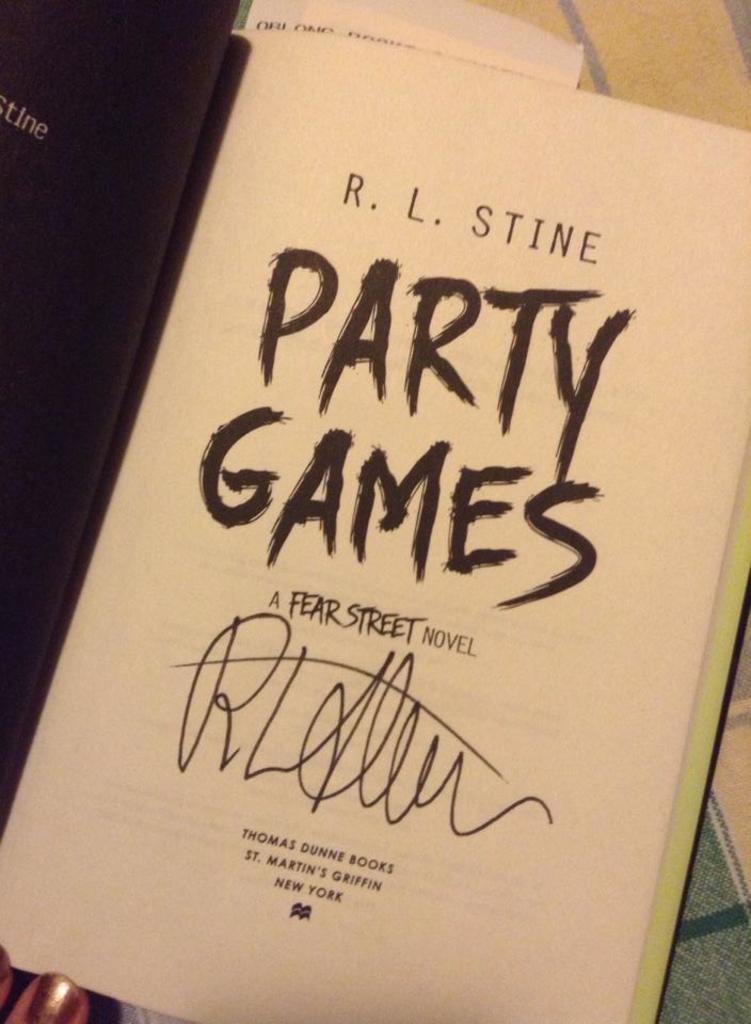What kind of novel is this?
Provide a succinct answer. Fear street. 